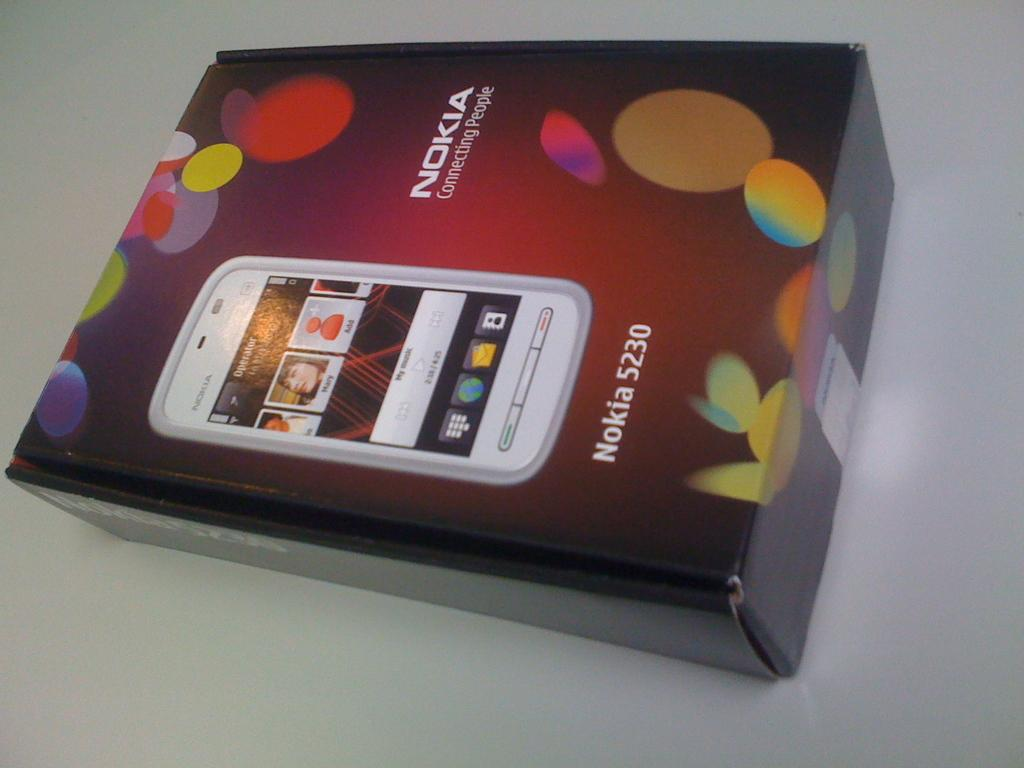<image>
Offer a succinct explanation of the picture presented. A Nokia 5230 phone box has multicolored circles on it. 